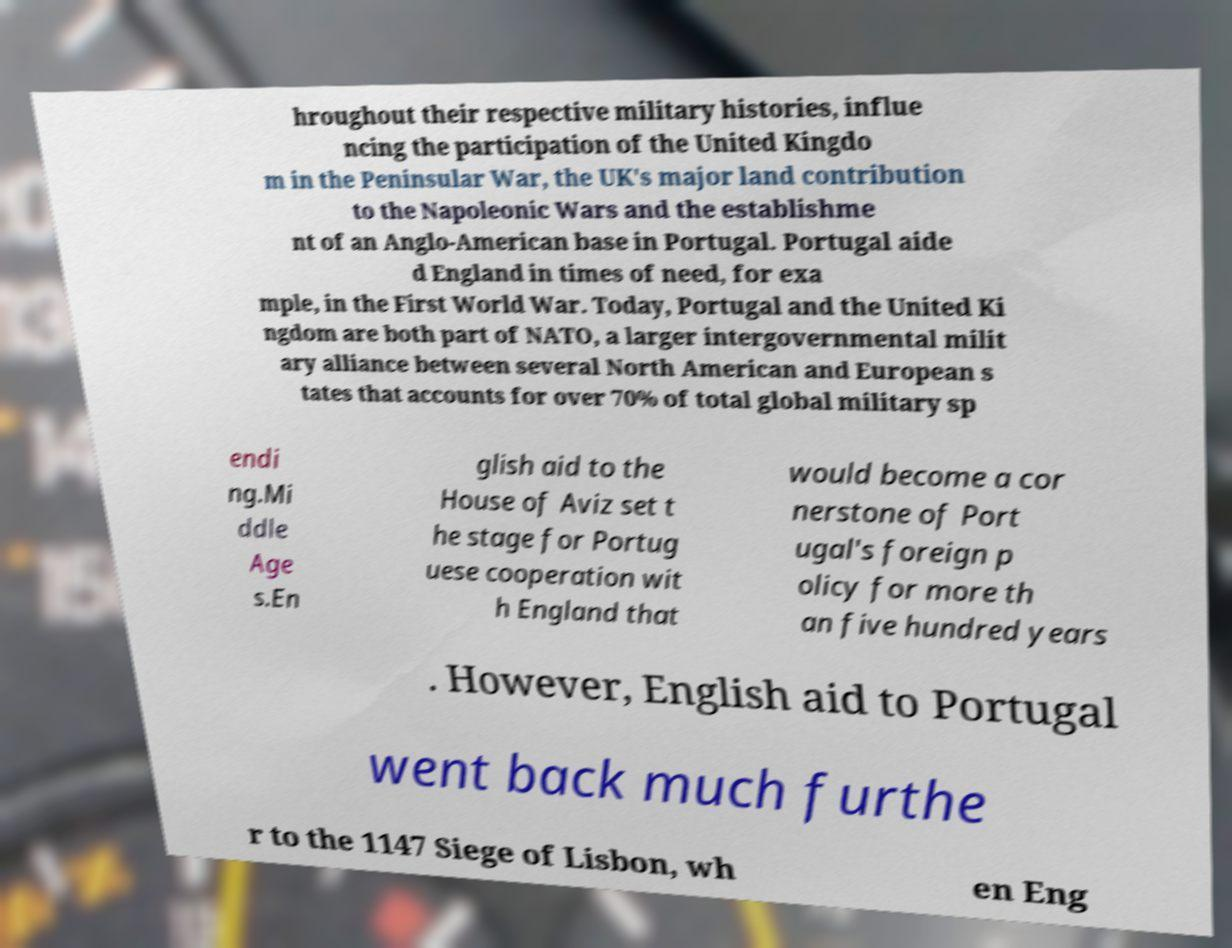Could you assist in decoding the text presented in this image and type it out clearly? hroughout their respective military histories, influe ncing the participation of the United Kingdo m in the Peninsular War, the UK's major land contribution to the Napoleonic Wars and the establishme nt of an Anglo-American base in Portugal. Portugal aide d England in times of need, for exa mple, in the First World War. Today, Portugal and the United Ki ngdom are both part of NATO, a larger intergovernmental milit ary alliance between several North American and European s tates that accounts for over 70% of total global military sp endi ng.Mi ddle Age s.En glish aid to the House of Aviz set t he stage for Portug uese cooperation wit h England that would become a cor nerstone of Port ugal's foreign p olicy for more th an five hundred years . However, English aid to Portugal went back much furthe r to the 1147 Siege of Lisbon, wh en Eng 